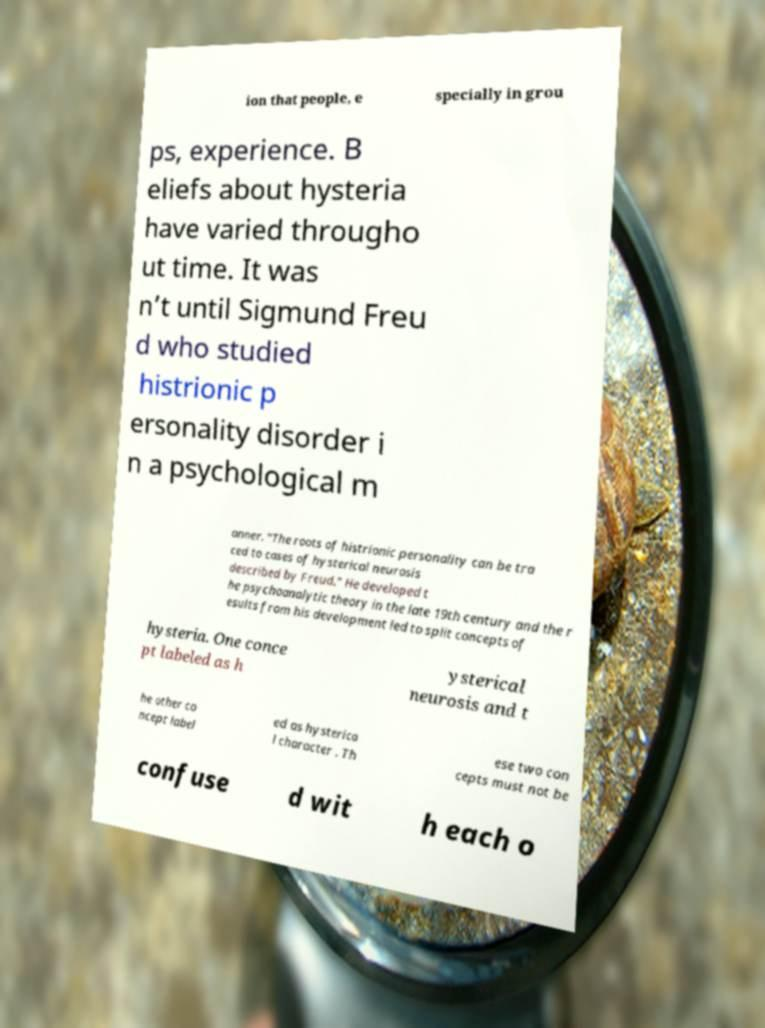Please identify and transcribe the text found in this image. ion that people, e specially in grou ps, experience. B eliefs about hysteria have varied througho ut time. It was n’t until Sigmund Freu d who studied histrionic p ersonality disorder i n a psychological m anner. “The roots of histrionic personality can be tra ced to cases of hysterical neurosis described by Freud.” He developed t he psychoanalytic theory in the late 19th century and the r esults from his development led to split concepts of hysteria. One conce pt labeled as h ysterical neurosis and t he other co ncept label ed as hysterica l character . Th ese two con cepts must not be confuse d wit h each o 